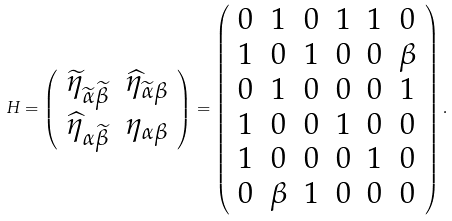Convert formula to latex. <formula><loc_0><loc_0><loc_500><loc_500>H = \left ( \begin{array} { c c } \widetilde { \eta } _ { \widetilde { \alpha } \widetilde { \beta } } & \widehat { \eta } _ { \widetilde { \alpha } \beta } \\ \widehat { \eta } _ { \alpha \widetilde { \beta } } & \eta _ { \alpha \beta } \end{array} \right ) = \left ( \begin{array} { c c c c c c } 0 & 1 & 0 & 1 & 1 & 0 \\ 1 & 0 & 1 & 0 & 0 & \beta \\ 0 & 1 & 0 & 0 & 0 & 1 \\ 1 & 0 & 0 & 1 & 0 & 0 \\ 1 & 0 & 0 & 0 & 1 & 0 \\ 0 & \beta & 1 & 0 & 0 & 0 \end{array} \right ) .</formula> 